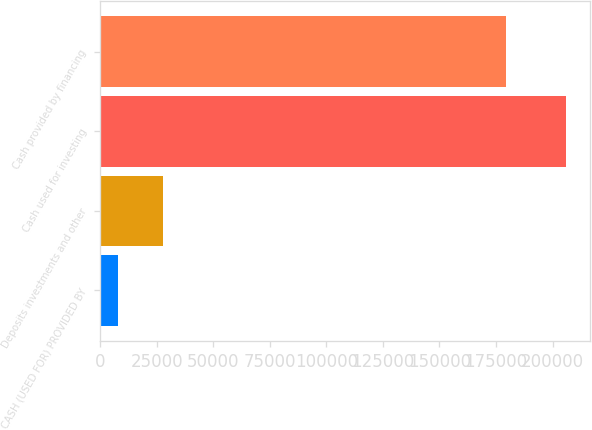<chart> <loc_0><loc_0><loc_500><loc_500><bar_chart><fcel>CASH (USED FOR) PROVIDED BY<fcel>Deposits investments and other<fcel>Cash used for investing<fcel>Cash provided by financing<nl><fcel>7841<fcel>27668.1<fcel>206112<fcel>179388<nl></chart> 